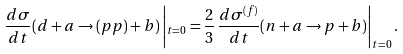<formula> <loc_0><loc_0><loc_500><loc_500>\frac { d \sigma } { d t } ( d + a \rightarrow ( p p ) + b ) \left | _ { t = 0 } = \frac { 2 } { 3 } \, \frac { d \sigma ^ { ( f ) } } { d t } ( n + a \rightarrow p + b ) \right | _ { t = 0 } .</formula> 